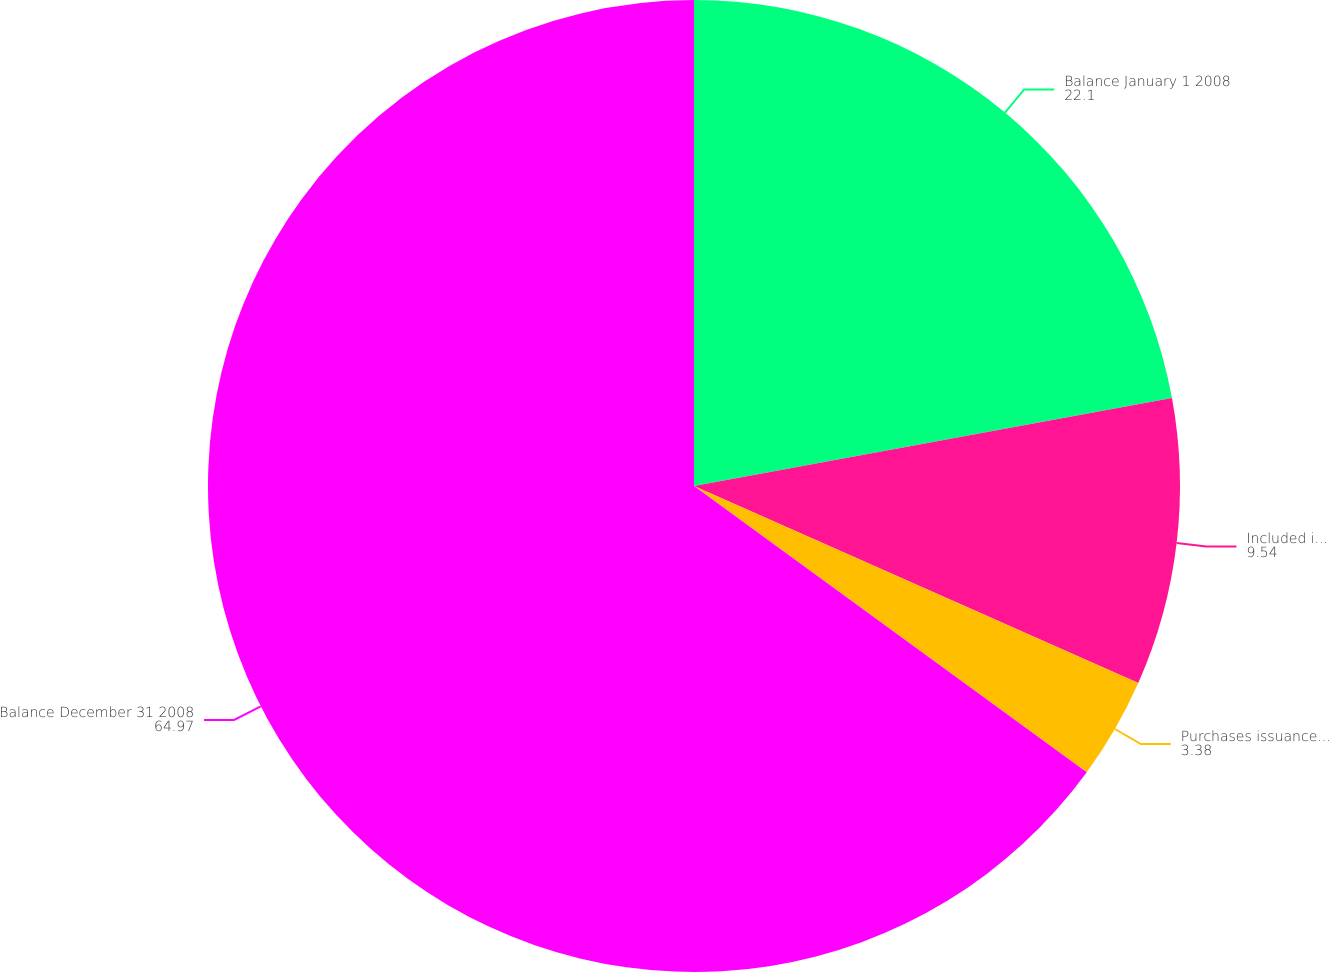<chart> <loc_0><loc_0><loc_500><loc_500><pie_chart><fcel>Balance January 1 2008<fcel>Included in earnings<fcel>Purchases issuances and<fcel>Balance December 31 2008<nl><fcel>22.1%<fcel>9.54%<fcel>3.38%<fcel>64.97%<nl></chart> 